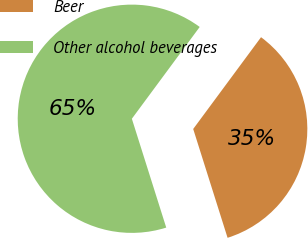Convert chart to OTSL. <chart><loc_0><loc_0><loc_500><loc_500><pie_chart><fcel>Beer<fcel>Other alcohol beverages<nl><fcel>35.0%<fcel>65.0%<nl></chart> 